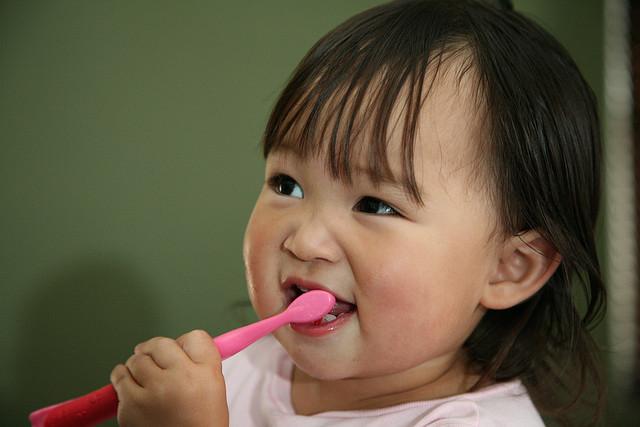Is this a boy or girl?
Be succinct. Girl. What color is the toothbrush?
Short answer required. Pink. Is it a girl or a boy?
Keep it brief. Girl. What is the girl holding in her hand?
Concise answer only. Toothbrush. What is the girl holding?
Give a very brief answer. Toothbrush. What is dangerous about this action?
Keep it brief. Choking. What color is the wall?
Give a very brief answer. Green. 